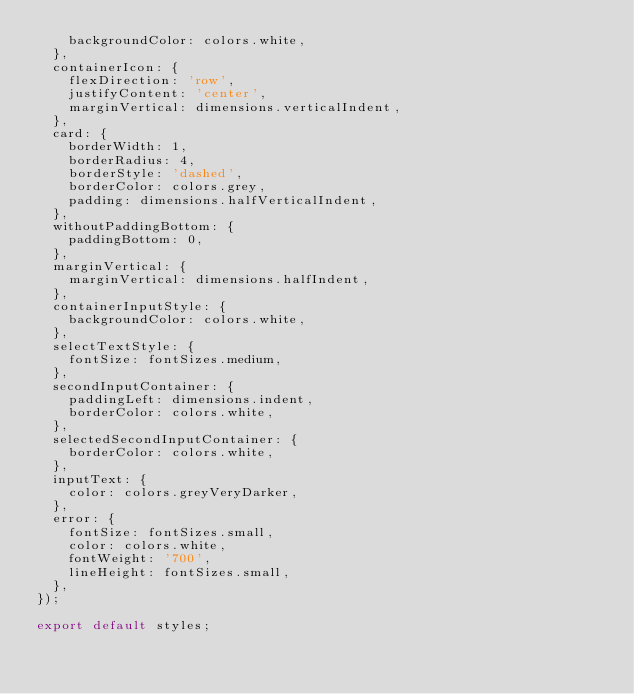<code> <loc_0><loc_0><loc_500><loc_500><_JavaScript_>    backgroundColor: colors.white,
  },
  containerIcon: {
    flexDirection: 'row',
    justifyContent: 'center',
    marginVertical: dimensions.verticalIndent,
  },
  card: {
    borderWidth: 1,
    borderRadius: 4,
    borderStyle: 'dashed',
    borderColor: colors.grey,
    padding: dimensions.halfVerticalIndent,
  },
  withoutPaddingBottom: {
    paddingBottom: 0,
  },
  marginVertical: {
    marginVertical: dimensions.halfIndent,
  },
  containerInputStyle: {
    backgroundColor: colors.white,
  },
  selectTextStyle: {
    fontSize: fontSizes.medium,
  },
  secondInputContainer: {
    paddingLeft: dimensions.indent,
    borderColor: colors.white,
  },
  selectedSecondInputContainer: {
    borderColor: colors.white,
  },
  inputText: {
    color: colors.greyVeryDarker,
  },
  error: {
    fontSize: fontSizes.small,
    color: colors.white,
    fontWeight: '700',
    lineHeight: fontSizes.small,
  },
});

export default styles;
</code> 